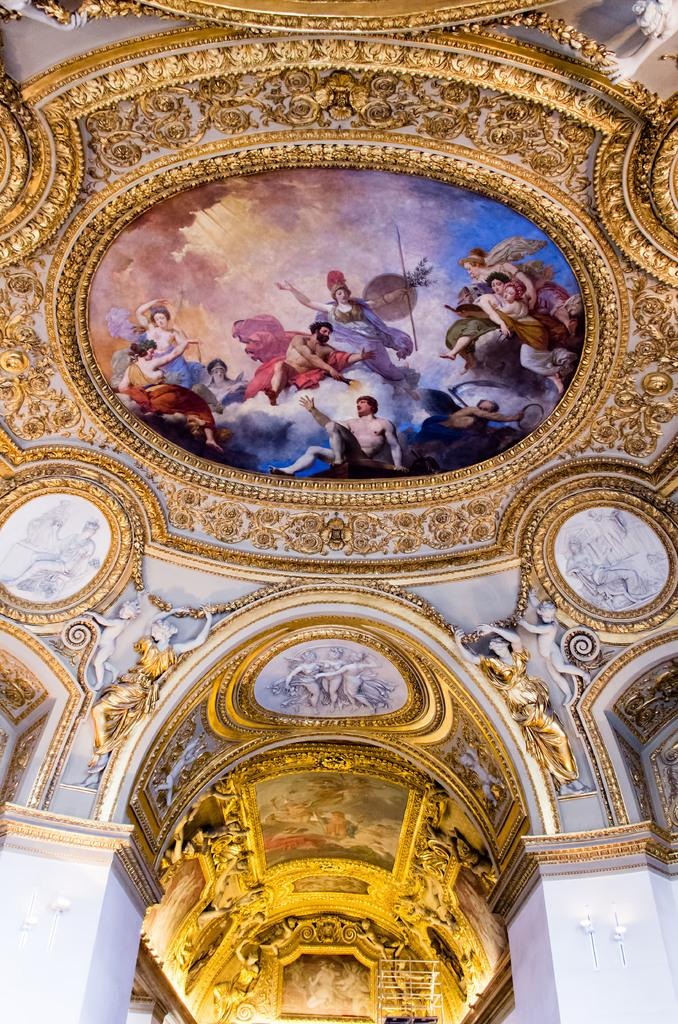What type of structure is present in the image? There is a building in the image. What part of the building can be seen? The roof of the building is visible. What is on the roof of the building? There is a painting on the roof of the building. What is depicted in the painting? The painting contains colorful images of persons. What type of oatmeal is being served at the organization's event in the image? There is no mention of oatmeal, an organization, or an event in the image. The image only shows a building with a painting on its roof. 